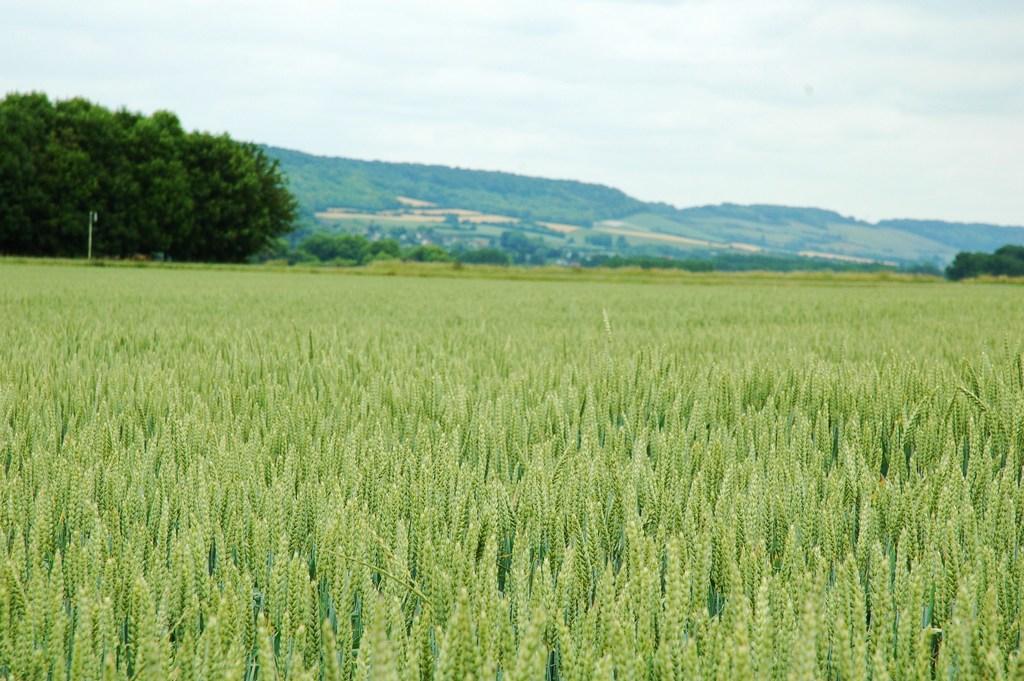Describe this image in one or two sentences. In this image there is a crop, in the background there are trees, mountain and the sky. 